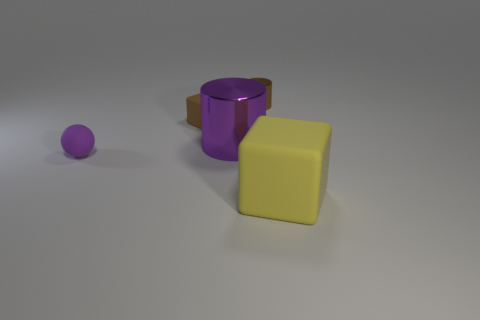What shapes can you identify in the image? There are four distinct shapes present: a small sphere, a cylinder, an angled cuboid or rectangular prism, and a cube. 